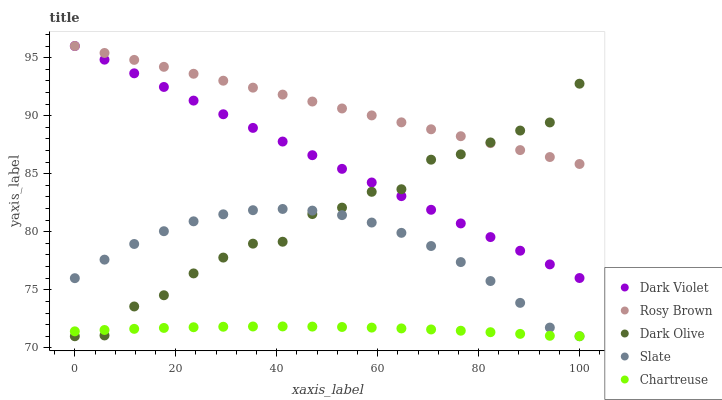Does Chartreuse have the minimum area under the curve?
Answer yes or no. Yes. Does Rosy Brown have the maximum area under the curve?
Answer yes or no. Yes. Does Slate have the minimum area under the curve?
Answer yes or no. No. Does Slate have the maximum area under the curve?
Answer yes or no. No. Is Dark Violet the smoothest?
Answer yes or no. Yes. Is Dark Olive the roughest?
Answer yes or no. Yes. Is Slate the smoothest?
Answer yes or no. No. Is Slate the roughest?
Answer yes or no. No. Does Dark Olive have the lowest value?
Answer yes or no. Yes. Does Rosy Brown have the lowest value?
Answer yes or no. No. Does Dark Violet have the highest value?
Answer yes or no. Yes. Does Slate have the highest value?
Answer yes or no. No. Is Slate less than Rosy Brown?
Answer yes or no. Yes. Is Dark Violet greater than Slate?
Answer yes or no. Yes. Does Slate intersect Chartreuse?
Answer yes or no. Yes. Is Slate less than Chartreuse?
Answer yes or no. No. Is Slate greater than Chartreuse?
Answer yes or no. No. Does Slate intersect Rosy Brown?
Answer yes or no. No. 